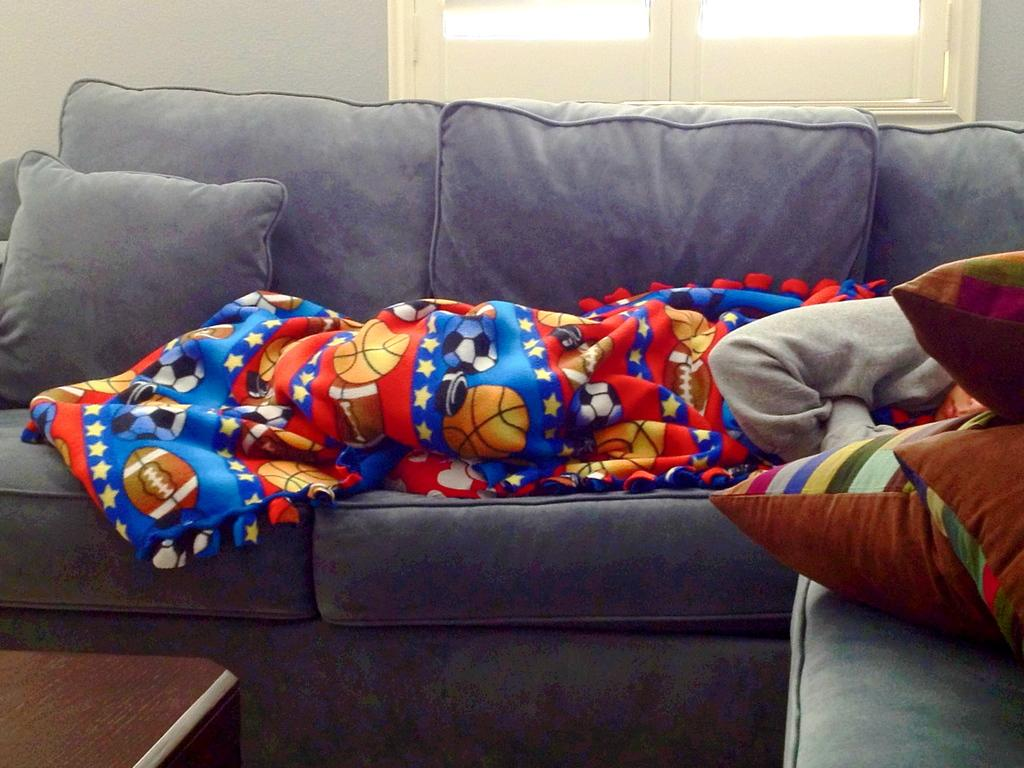What type of furniture is present in the image? There is a sofa with pillows in the image. What is covering the sofa? There is a bed sheet on the sofa. What other piece of furniture can be seen in the image? There is a table in the image. What can be seen in the background of the image? There is a wall and a window in the background of the image. How many grapes are visible on the table in the image? A: There are no grapes present on the table in the image. What color are the eyes of the person sitting on the sofa? There is no person sitting on the sofa in the image. 